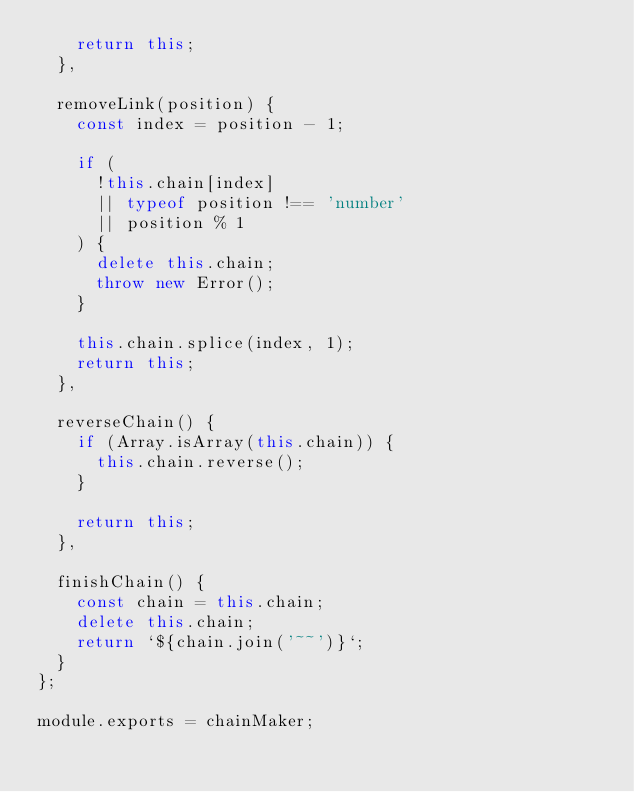<code> <loc_0><loc_0><loc_500><loc_500><_JavaScript_>    return this;
  },

  removeLink(position) {
    const index = position - 1;
    
    if (
      !this.chain[index]
      || typeof position !== 'number'
      || position % 1
    ) {
      delete this.chain;
      throw new Error();
    }

    this.chain.splice(index, 1);
    return this;
  },

  reverseChain() {
    if (Array.isArray(this.chain)) {
      this.chain.reverse();
    }

    return this;
  },

  finishChain() {
    const chain = this.chain;
    delete this.chain;
    return `${chain.join('~~')}`;
  }
};

module.exports = chainMaker;
</code> 